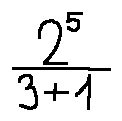Convert formula to latex. <formula><loc_0><loc_0><loc_500><loc_500>\frac { 2 ^ { 5 } } { 3 + 1 }</formula> 